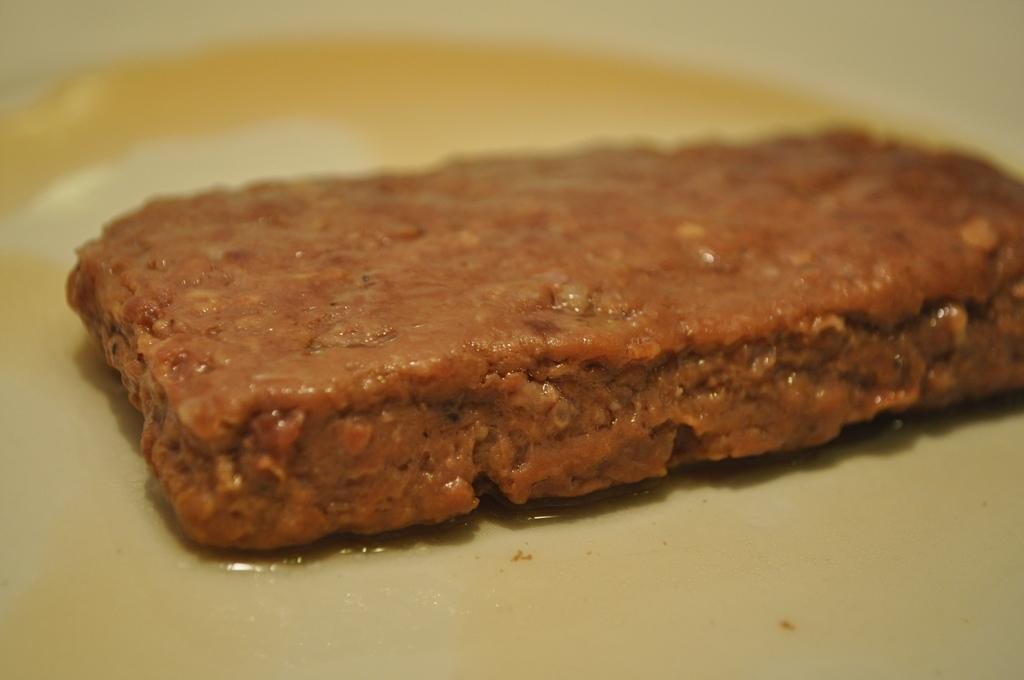What is on the plate in the image? There is food on a plate in the image. What type of pail is being used to serve the food in the image? There is no pail present in the image; the food is served on a plate. What shape is the apple on the plate in the image? There is no apple present in the image; the plate contains food, but the specific type of food is not mentioned. 